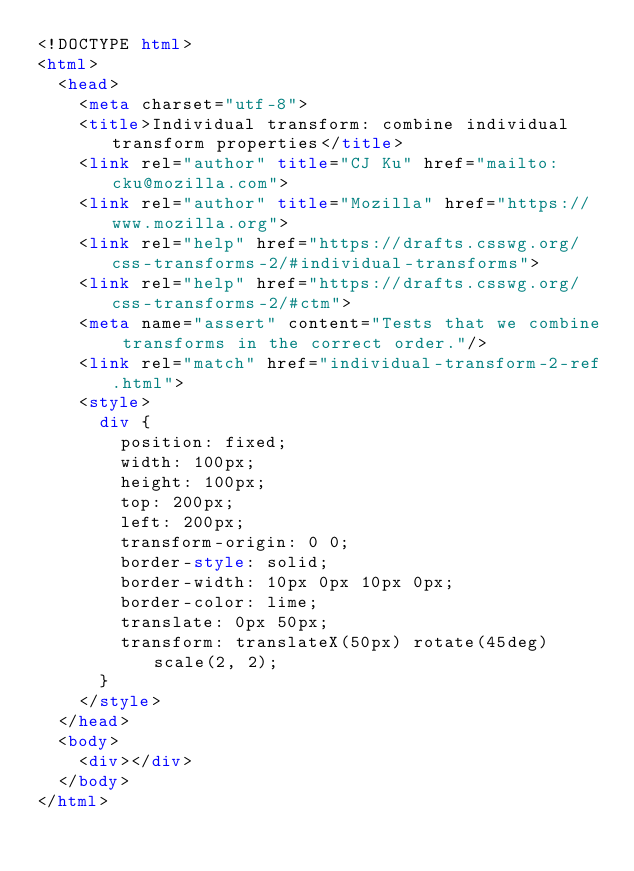<code> <loc_0><loc_0><loc_500><loc_500><_HTML_><!DOCTYPE html>
<html>
  <head>
    <meta charset="utf-8">
    <title>Individual transform: combine individual transform properties</title>
    <link rel="author" title="CJ Ku" href="mailto:cku@mozilla.com">
    <link rel="author" title="Mozilla" href="https://www.mozilla.org">
    <link rel="help" href="https://drafts.csswg.org/css-transforms-2/#individual-transforms">
    <link rel="help" href="https://drafts.csswg.org/css-transforms-2/#ctm">
    <meta name="assert" content="Tests that we combine transforms in the correct order."/>
    <link rel="match" href="individual-transform-2-ref.html">
    <style>
      div {
        position: fixed;
        width: 100px;
        height: 100px;
        top: 200px;
        left: 200px;
        transform-origin: 0 0;
        border-style: solid;
        border-width: 10px 0px 10px 0px;
        border-color: lime;
        translate: 0px 50px;
        transform: translateX(50px) rotate(45deg) scale(2, 2);
      }
    </style>
  </head>
  <body>
    <div></div>
  </body>
</html>
</code> 